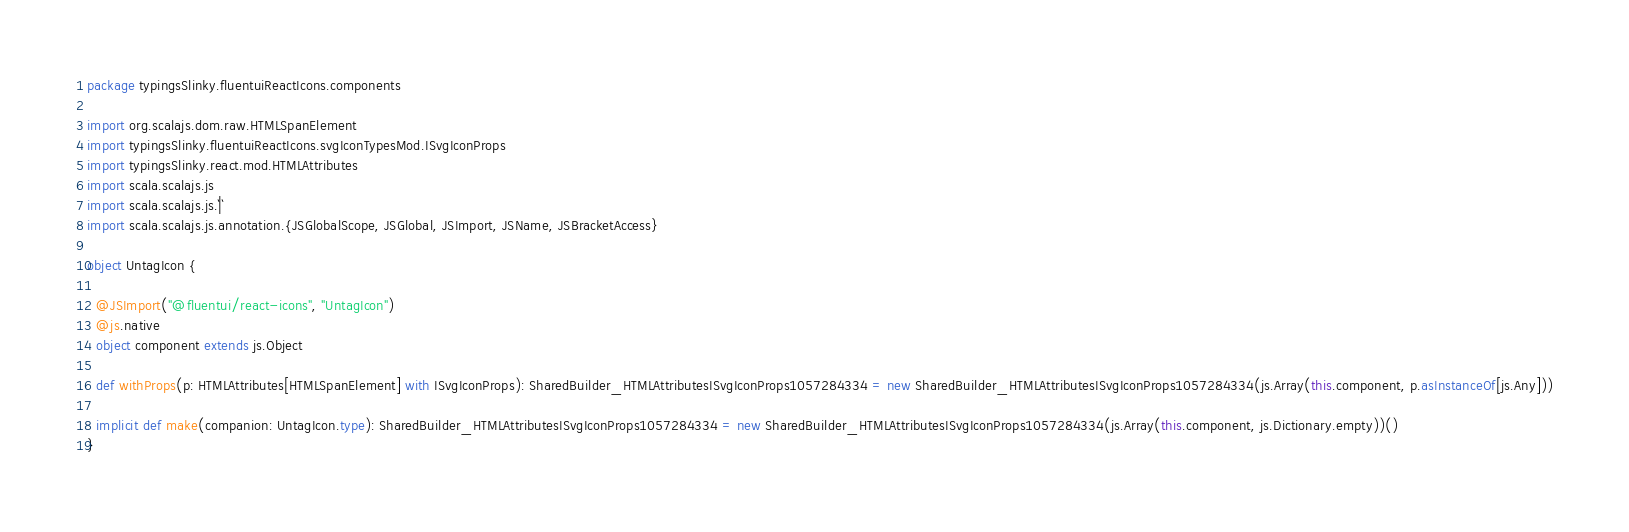<code> <loc_0><loc_0><loc_500><loc_500><_Scala_>package typingsSlinky.fluentuiReactIcons.components

import org.scalajs.dom.raw.HTMLSpanElement
import typingsSlinky.fluentuiReactIcons.svgIconTypesMod.ISvgIconProps
import typingsSlinky.react.mod.HTMLAttributes
import scala.scalajs.js
import scala.scalajs.js.`|`
import scala.scalajs.js.annotation.{JSGlobalScope, JSGlobal, JSImport, JSName, JSBracketAccess}

object UntagIcon {
  
  @JSImport("@fluentui/react-icons", "UntagIcon")
  @js.native
  object component extends js.Object
  
  def withProps(p: HTMLAttributes[HTMLSpanElement] with ISvgIconProps): SharedBuilder_HTMLAttributesISvgIconProps1057284334 = new SharedBuilder_HTMLAttributesISvgIconProps1057284334(js.Array(this.component, p.asInstanceOf[js.Any]))
  
  implicit def make(companion: UntagIcon.type): SharedBuilder_HTMLAttributesISvgIconProps1057284334 = new SharedBuilder_HTMLAttributesISvgIconProps1057284334(js.Array(this.component, js.Dictionary.empty))()
}
</code> 